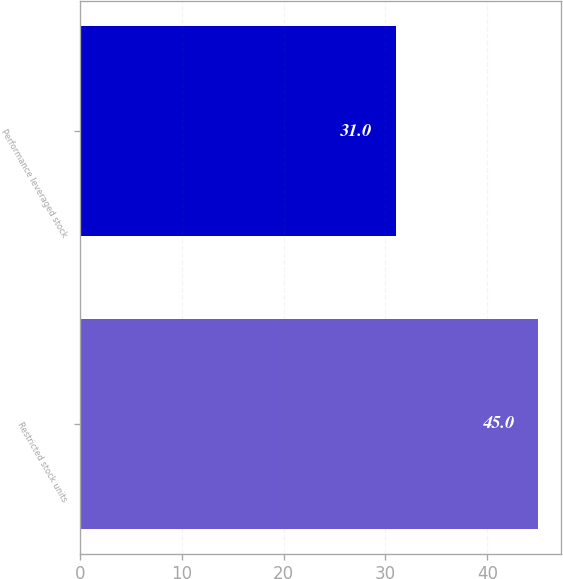<chart> <loc_0><loc_0><loc_500><loc_500><bar_chart><fcel>Restricted stock units<fcel>Performance leveraged stock<nl><fcel>45<fcel>31<nl></chart> 